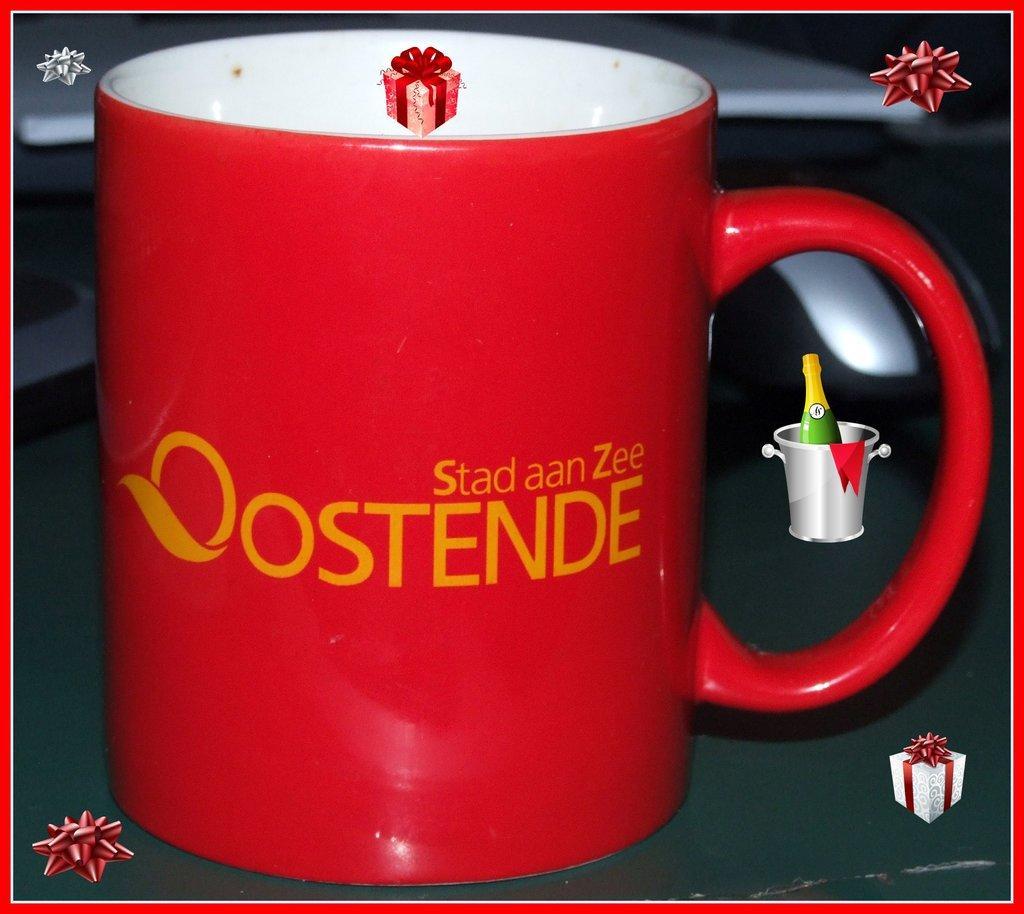Describe this image in one or two sentences. in the image we can see a coffee cup, red in color and on it there is a text, yellow in color. We can even see there are watermarks. 